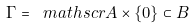Convert formula to latex. <formula><loc_0><loc_0><loc_500><loc_500>\Gamma = \ m a t h s c r { A } \times \{ 0 \} \subset B</formula> 